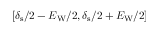Convert formula to latex. <formula><loc_0><loc_0><loc_500><loc_500>[ \delta _ { s } / 2 - E _ { W } / 2 , \delta _ { s } / 2 + E _ { W } / 2 ]</formula> 